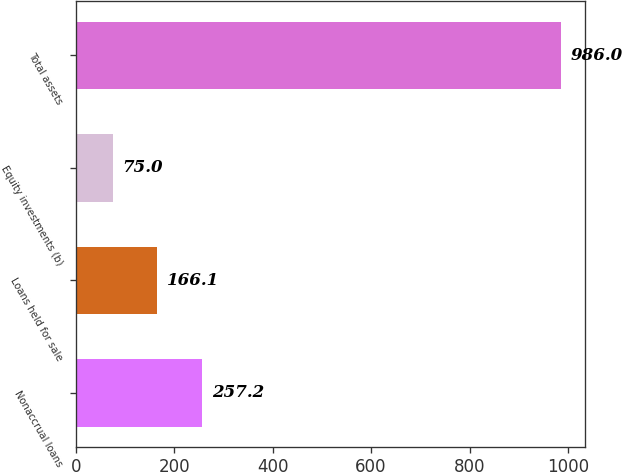Convert chart to OTSL. <chart><loc_0><loc_0><loc_500><loc_500><bar_chart><fcel>Nonaccrual loans<fcel>Loans held for sale<fcel>Equity investments (b)<fcel>Total assets<nl><fcel>257.2<fcel>166.1<fcel>75<fcel>986<nl></chart> 